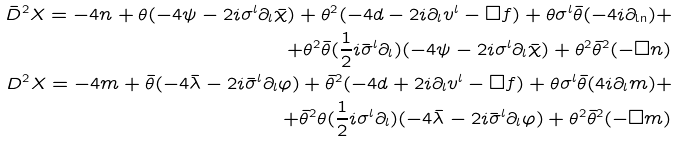<formula> <loc_0><loc_0><loc_500><loc_500>\bar { D } ^ { 2 } X = - 4 n + \theta ( - 4 \psi - 2 i \sigma ^ { l } \partial _ { l } \bar { \chi } ) + \theta ^ { 2 } ( - 4 d - 2 i \partial _ { l } v ^ { l } - \square f ) + \theta \sigma ^ { l } \bar { \theta } ( - 4 i \partial _ { \ln } ) + \\ + \theta ^ { 2 } \bar { \theta } ( \frac { 1 } { 2 } i \bar { \sigma } ^ { l } \partial _ { l } ) ( - 4 \psi - 2 i \sigma ^ { l } \partial _ { l } \bar { \chi } ) + \theta ^ { 2 } \bar { \theta } ^ { 2 } ( - \square n ) \\ D ^ { 2 } X = - 4 m + \bar { \theta } ( - 4 \bar { \lambda } - 2 i \bar { \sigma } ^ { l } \partial _ { l } \varphi ) + \bar { \theta } ^ { 2 } ( - 4 d + 2 i \partial _ { l } v ^ { l } - \square f ) + \theta \sigma ^ { l } \bar { \theta } ( 4 i \partial _ { l } m ) + \\ + \bar { \theta } ^ { 2 } \theta ( \frac { 1 } { 2 } i \sigma ^ { l } \partial _ { l } ) ( - 4 \bar { \lambda } - 2 i \bar { \sigma } ^ { l } \partial _ { l } \varphi ) + \theta ^ { 2 } \bar { \theta } ^ { 2 } ( - \square m )</formula> 